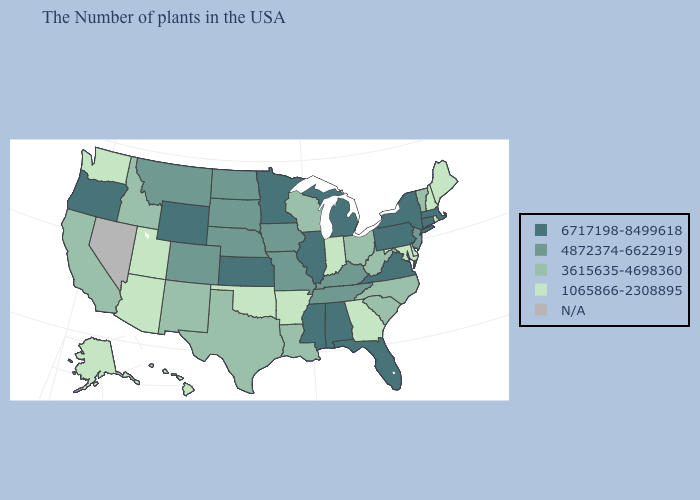Which states have the lowest value in the Northeast?
Be succinct. Maine, Rhode Island, New Hampshire. What is the value of Rhode Island?
Quick response, please. 1065866-2308895. Which states have the highest value in the USA?
Give a very brief answer. Massachusetts, Connecticut, New York, Pennsylvania, Virginia, Florida, Michigan, Alabama, Illinois, Mississippi, Minnesota, Kansas, Wyoming, Oregon. What is the highest value in the Northeast ?
Write a very short answer. 6717198-8499618. Does Arkansas have the highest value in the USA?
Concise answer only. No. What is the lowest value in the Northeast?
Be succinct. 1065866-2308895. Name the states that have a value in the range 1065866-2308895?
Give a very brief answer. Maine, Rhode Island, New Hampshire, Delaware, Maryland, Georgia, Indiana, Arkansas, Oklahoma, Utah, Arizona, Washington, Alaska, Hawaii. What is the value of Texas?
Be succinct. 3615635-4698360. Name the states that have a value in the range 6717198-8499618?
Quick response, please. Massachusetts, Connecticut, New York, Pennsylvania, Virginia, Florida, Michigan, Alabama, Illinois, Mississippi, Minnesota, Kansas, Wyoming, Oregon. Does the map have missing data?
Answer briefly. Yes. Among the states that border Nebraska , does Kansas have the highest value?
Short answer required. Yes. What is the value of Illinois?
Write a very short answer. 6717198-8499618. What is the value of Colorado?
Give a very brief answer. 4872374-6622919. 